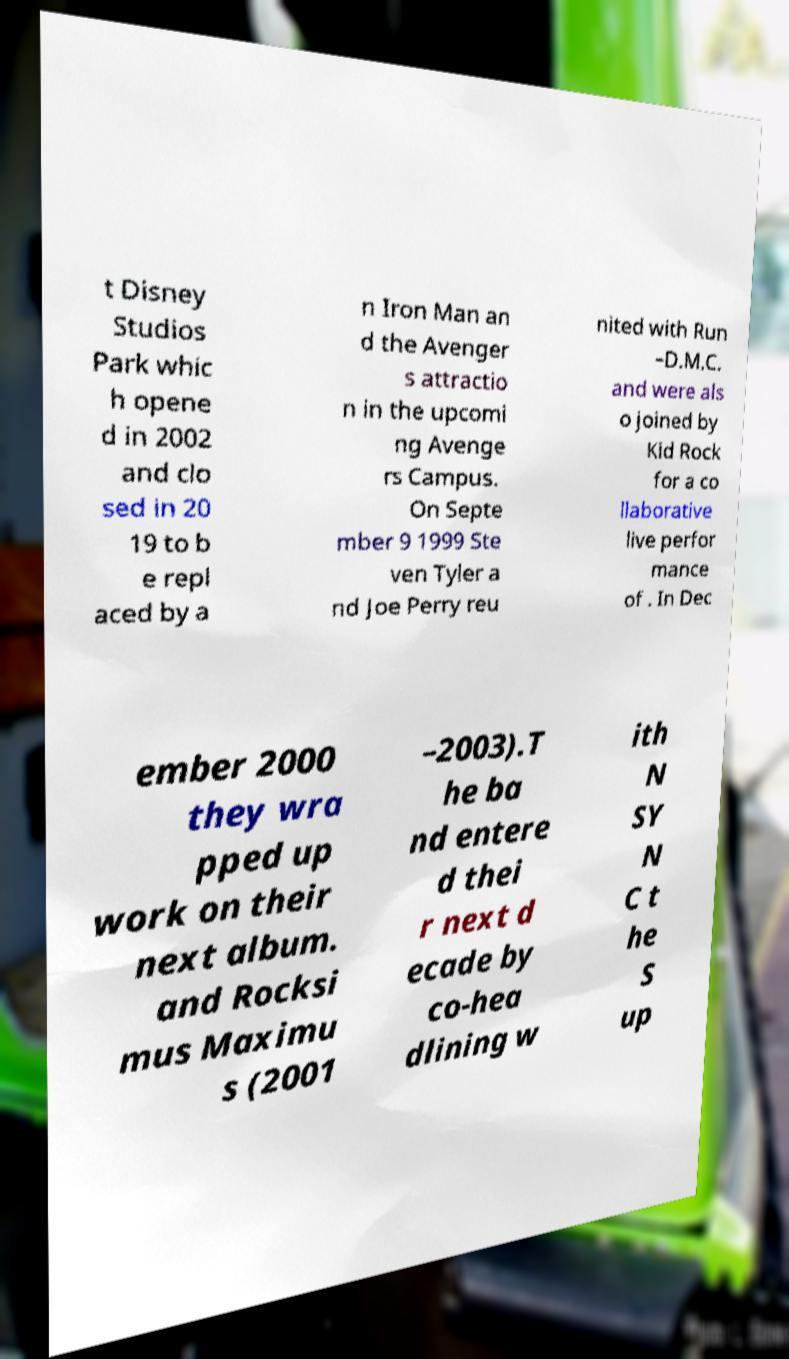There's text embedded in this image that I need extracted. Can you transcribe it verbatim? t Disney Studios Park whic h opene d in 2002 and clo sed in 20 19 to b e repl aced by a n Iron Man an d the Avenger s attractio n in the upcomi ng Avenge rs Campus. On Septe mber 9 1999 Ste ven Tyler a nd Joe Perry reu nited with Run –D.M.C. and were als o joined by Kid Rock for a co llaborative live perfor mance of . In Dec ember 2000 they wra pped up work on their next album. and Rocksi mus Maximu s (2001 –2003).T he ba nd entere d thei r next d ecade by co-hea dlining w ith N SY N C t he S up 